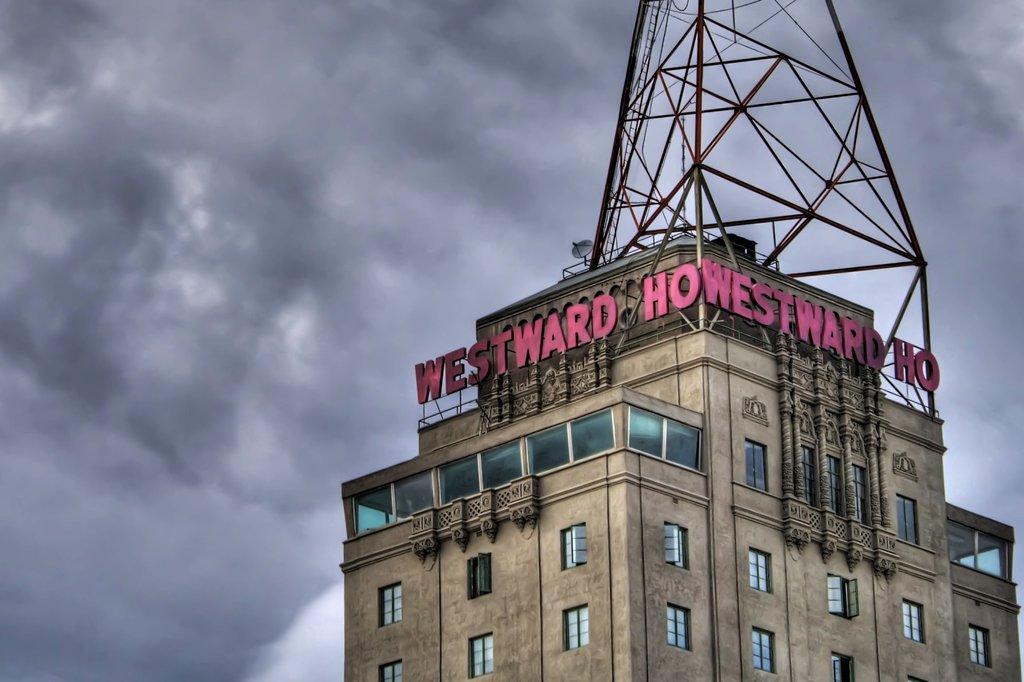How would you summarize this image in a sentence or two? In this picture we can see a building and few windows on this building. We can see a dish TV on this building. Sky is cloudy. 